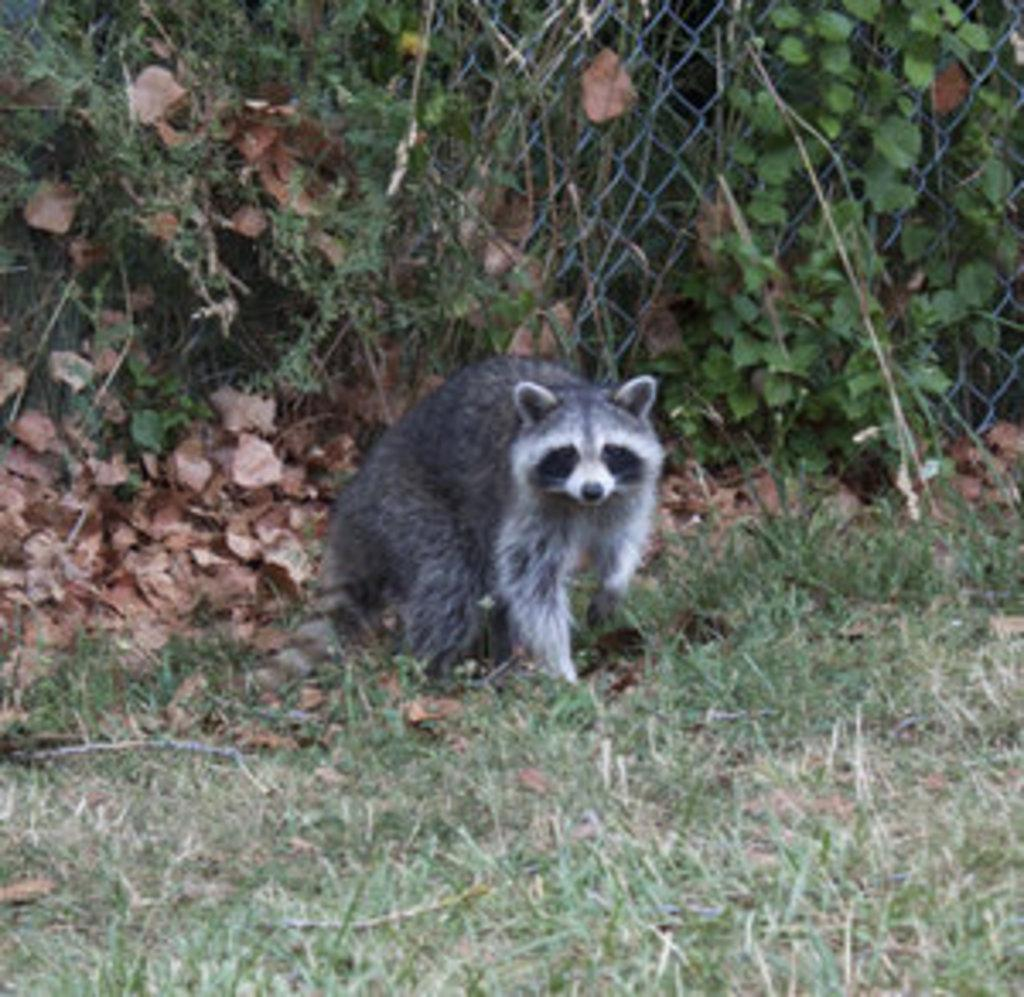What is the main subject in the center of the image? There is an animal in the center of the image. What can be seen in the background of the image? There is a mesh and plants in the background of the image. What type of vegetation is visible at the bottom of the image? There is grass at the bottom of the image. What is the tendency of the bikes in the image? There are no bikes present in the image, so it is not possible to determine their tendency. 